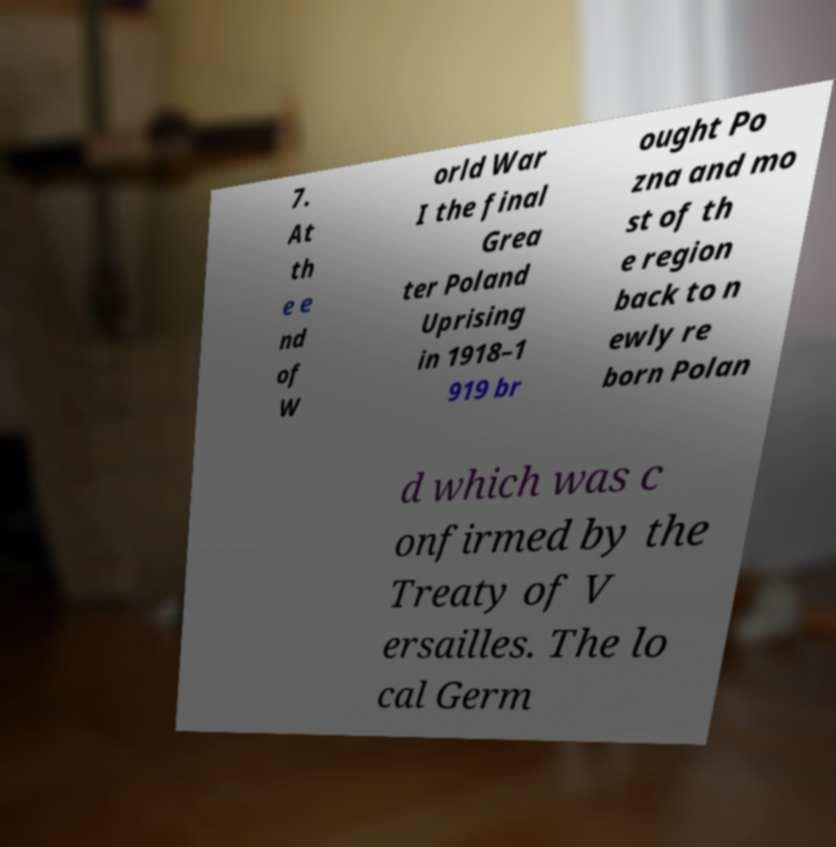Could you assist in decoding the text presented in this image and type it out clearly? 7. At th e e nd of W orld War I the final Grea ter Poland Uprising in 1918–1 919 br ought Po zna and mo st of th e region back to n ewly re born Polan d which was c onfirmed by the Treaty of V ersailles. The lo cal Germ 